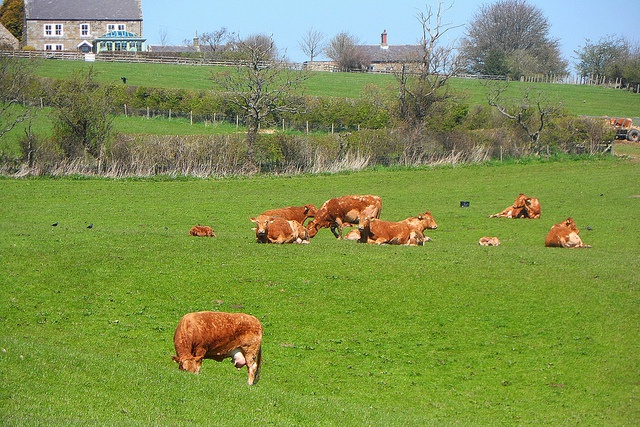Describe the objects in this image and their specific colors. I can see cow in lightblue, brown, tan, maroon, and red tones, cow in lightblue, brown, tan, maroon, and black tones, cow in lightblue, tan, brown, red, and black tones, cow in lightblue, tan, brown, red, and black tones, and cow in lightblue, brown, tan, and red tones in this image. 